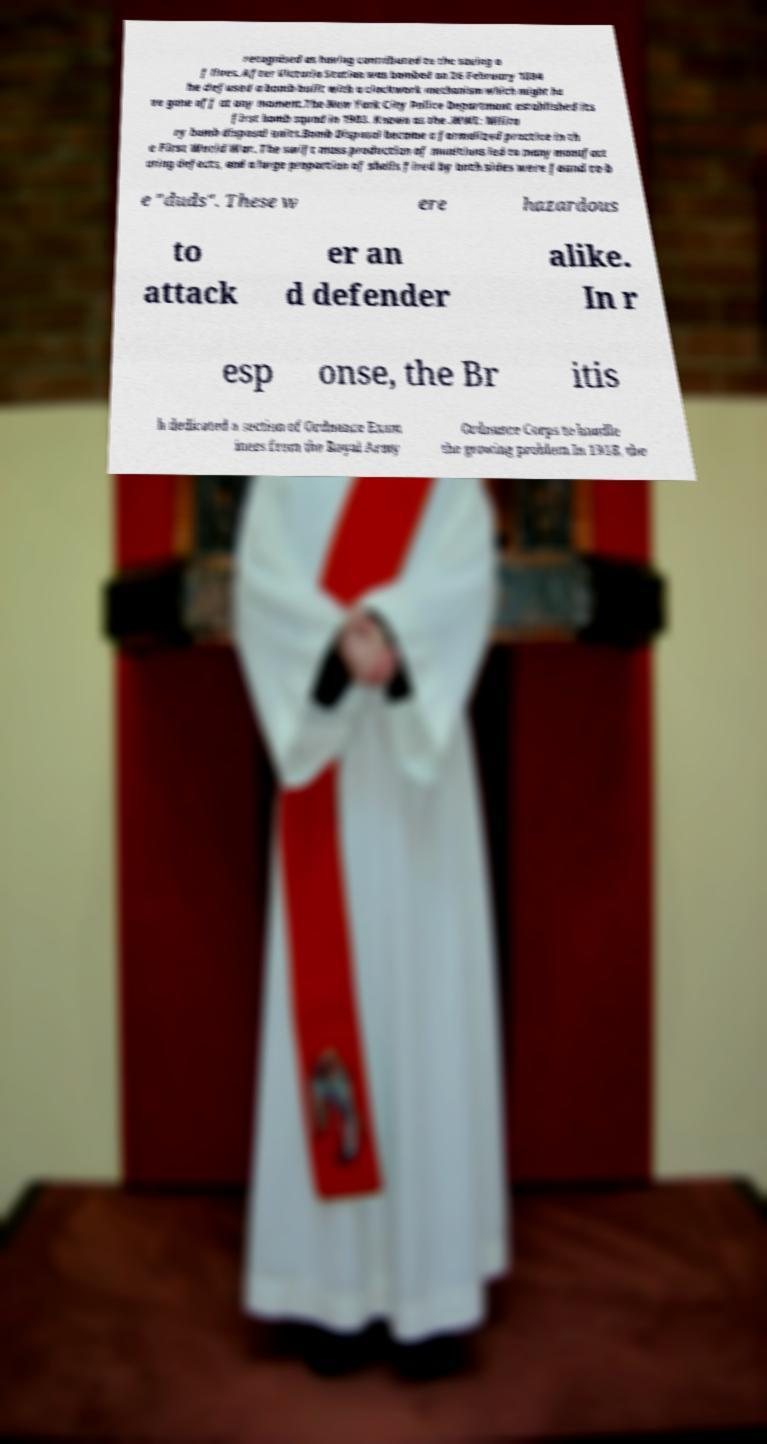I need the written content from this picture converted into text. Can you do that? recognised as having contributed to the saving o f lives. After Victoria Station was bombed on 26 February 1884 he defused a bomb built with a clockwork mechanism which might ha ve gone off at any moment.The New York City Police Department established its first bomb squad in 1903. Known as the .WWI: Milita ry bomb disposal units.Bomb Disposal became a formalized practice in th e First World War. The swift mass production of munitions led to many manufact uring defects, and a large proportion of shells fired by both sides were found to b e "duds". These w ere hazardous to attack er an d defender alike. In r esp onse, the Br itis h dedicated a section of Ordnance Exam iners from the Royal Army Ordnance Corps to handle the growing problem.In 1918, the 